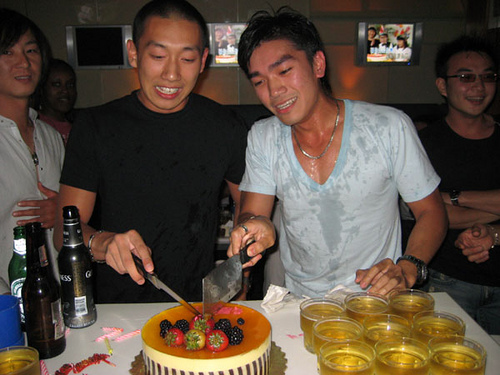Is the guy with the glasses right handed? Yes, the guy with the glasses is using his right hand. 